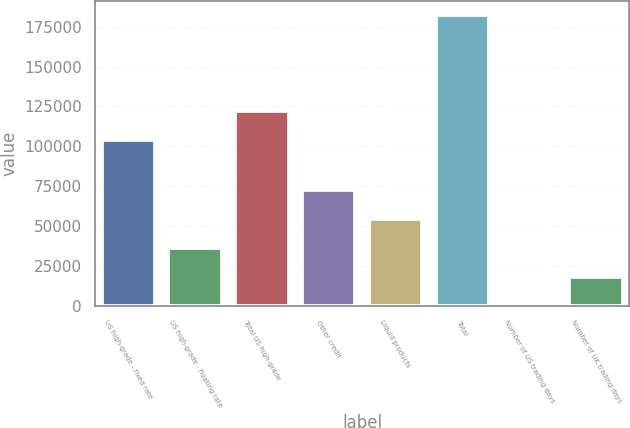Convert chart. <chart><loc_0><loc_0><loc_500><loc_500><bar_chart><fcel>US high-grade - fixed rate<fcel>US high-grade - floating rate<fcel>Total US high-grade<fcel>Other credit<fcel>Liquid products<fcel>Total<fcel>Number of US trading days<fcel>Number of UK trading days<nl><fcel>104143<fcel>36478.8<fcel>122350<fcel>72893.6<fcel>54686.2<fcel>182138<fcel>64<fcel>18271.4<nl></chart> 